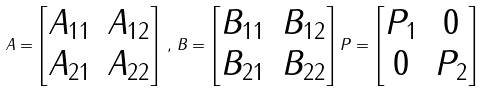Convert formula to latex. <formula><loc_0><loc_0><loc_500><loc_500>A = \begin{bmatrix} A _ { 1 1 } & A _ { 1 2 } \\ A _ { 2 1 } & A _ { 2 2 } \end{bmatrix} \, , \, B = \begin{bmatrix} B _ { 1 1 } & B _ { 1 2 } \\ B _ { 2 1 } & B _ { 2 2 } \end{bmatrix} P = \begin{bmatrix} P _ { 1 } & 0 \\ 0 & P _ { 2 } \end{bmatrix}</formula> 